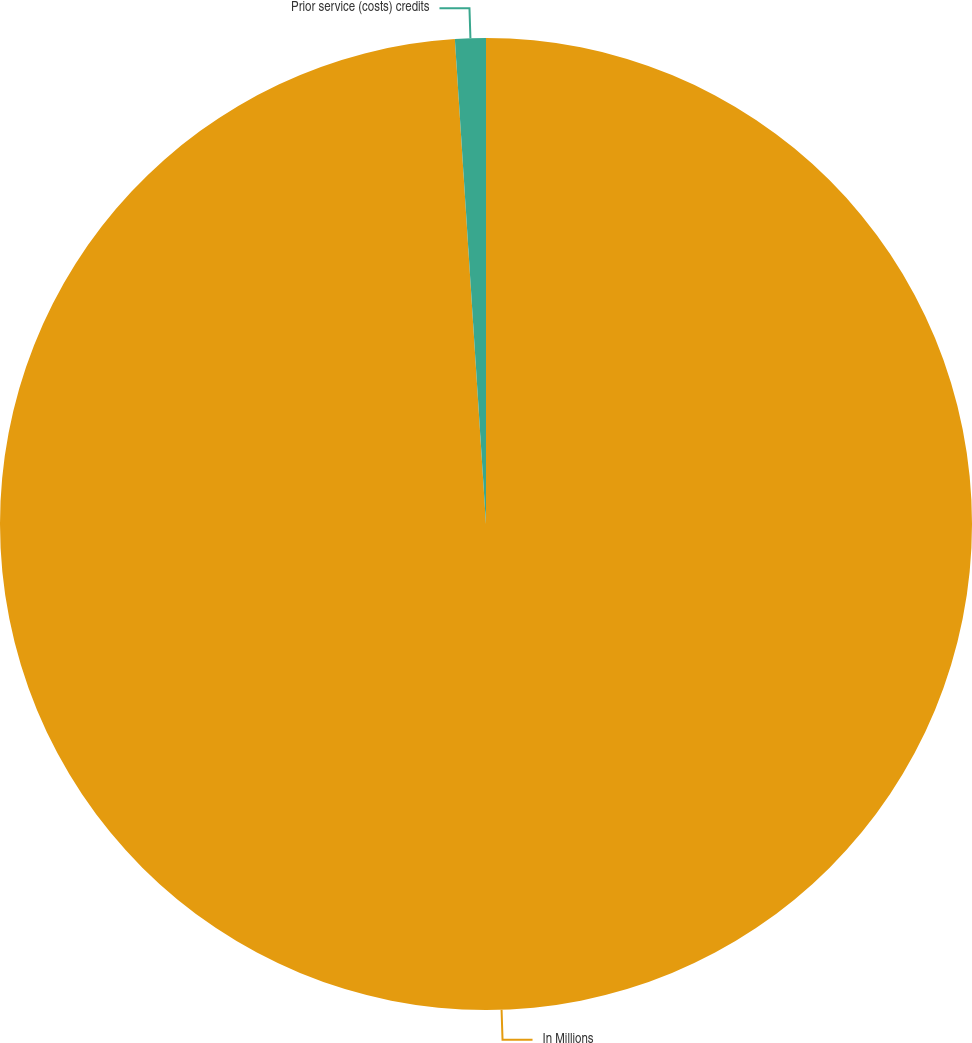Convert chart. <chart><loc_0><loc_0><loc_500><loc_500><pie_chart><fcel>In Millions<fcel>Prior service (costs) credits<nl><fcel>98.98%<fcel>1.02%<nl></chart> 